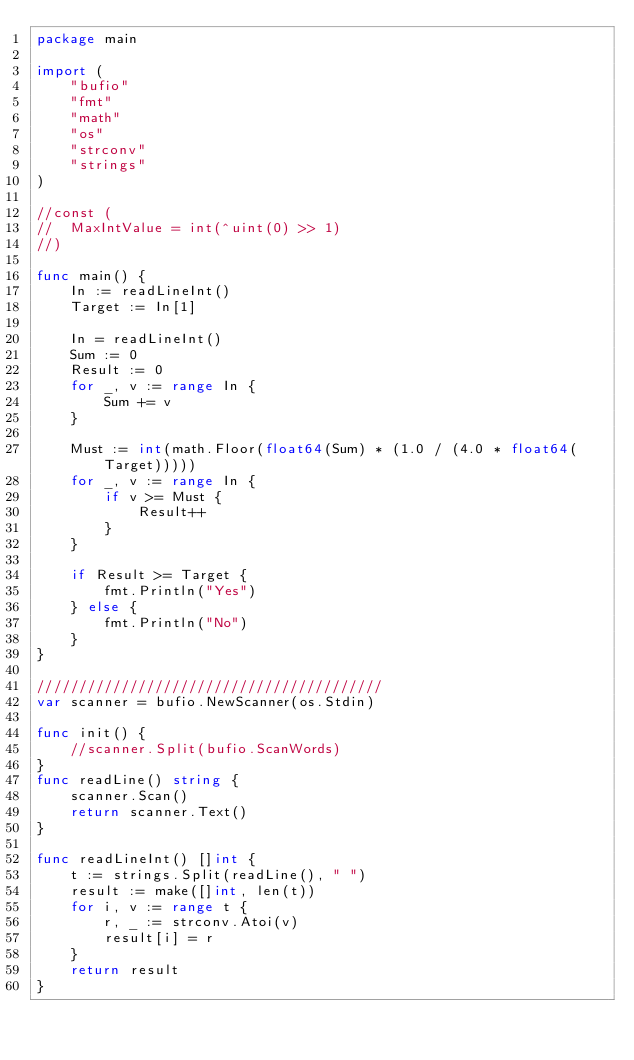<code> <loc_0><loc_0><loc_500><loc_500><_Go_>package main

import (
	"bufio"
	"fmt"
	"math"
	"os"
	"strconv"
	"strings"
)

//const (
//	MaxIntValue = int(^uint(0) >> 1)
//)

func main() {
	In := readLineInt()
	Target := In[1]

	In = readLineInt()
	Sum := 0
	Result := 0
	for _, v := range In {
		Sum += v
	}

	Must := int(math.Floor(float64(Sum) * (1.0 / (4.0 * float64(Target)))))
	for _, v := range In {
		if v >= Must {
			Result++
		}
	}

	if Result >= Target {
		fmt.Println("Yes")
	} else {
		fmt.Println("No")
	}
}

/////////////////////////////////////////
var scanner = bufio.NewScanner(os.Stdin)

func init() {
	//scanner.Split(bufio.ScanWords)
}
func readLine() string {
	scanner.Scan()
	return scanner.Text()
}

func readLineInt() []int {
	t := strings.Split(readLine(), " ")
	result := make([]int, len(t))
	for i, v := range t {
		r, _ := strconv.Atoi(v)
		result[i] = r
	}
	return result
}
</code> 